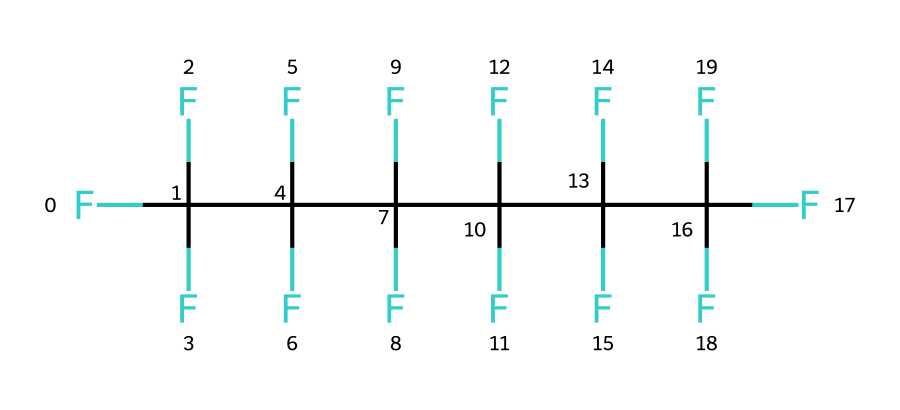how many carbon atoms are present in this structure? By examining the SMILES representation, we see that there are multiple occurrences of 'C', each indicating a carbon atom. Counting these occurrences gives a total of six carbon atoms.
Answer: six how many fluorine atoms are connected to the carbon chain? In the given structure, each carbon is bonded to three fluorine atoms, and with six carbon atoms, that results in a total of eighteen fluorine atoms (6 carbon x 3 fluorine per carbon).
Answer: eighteen what is the type of bonding present between the carbon and fluorine atoms? The chemical bonding in this structure consists of single covalent bonds between carbon and fluorine atoms, as indicated by the way the carbons are attached to multiple fluorines without any double or triple bonding shown.
Answer: single covalent what is the primary characteristic of this chemical related to its use in non-stick coatings? This chemical has a very stable structure due to the strong bond between carbon and fluorine, which contributes to its non-stick properties. The high electronegativity of fluorine creates a low surface energy.
Answer: non-stick does this chemical structure contain any oxygen atoms? Upon analyzing the SMILES notation, there are no 'O' characters present, indicating that there are no oxygen atoms in this chemical structure.
Answer: no what kind of environmental concerns are associated with chemicals like this? Chemicals that contain a high number of fluorine atoms, especially in long-chain compounds, can lead to environmental persistence and bioaccumulation, raising concerns about their impact on ecosystems and human health.
Answer: environmental persistence 